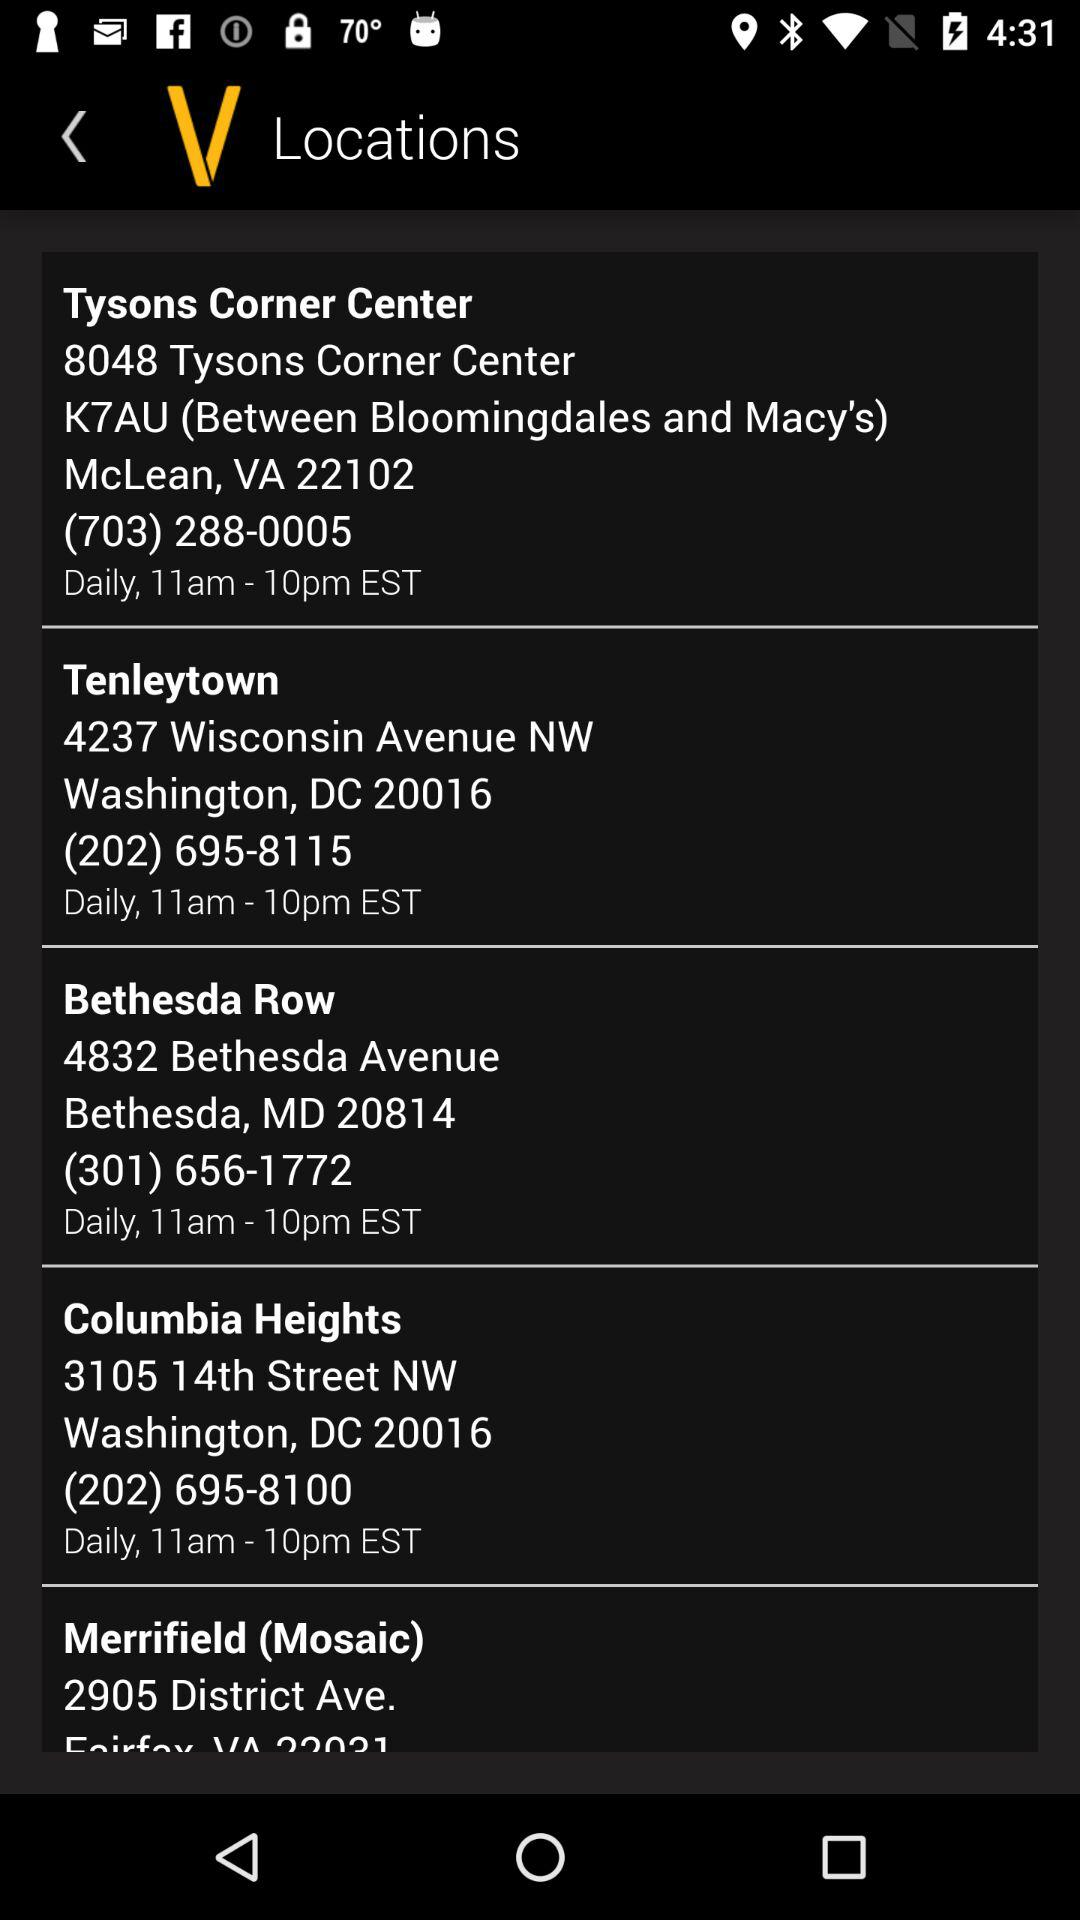What is the address of Tenleytown? The address of Tenleytown is 4237 Wisconsin Avenue NW, Washington, DC 20016. 